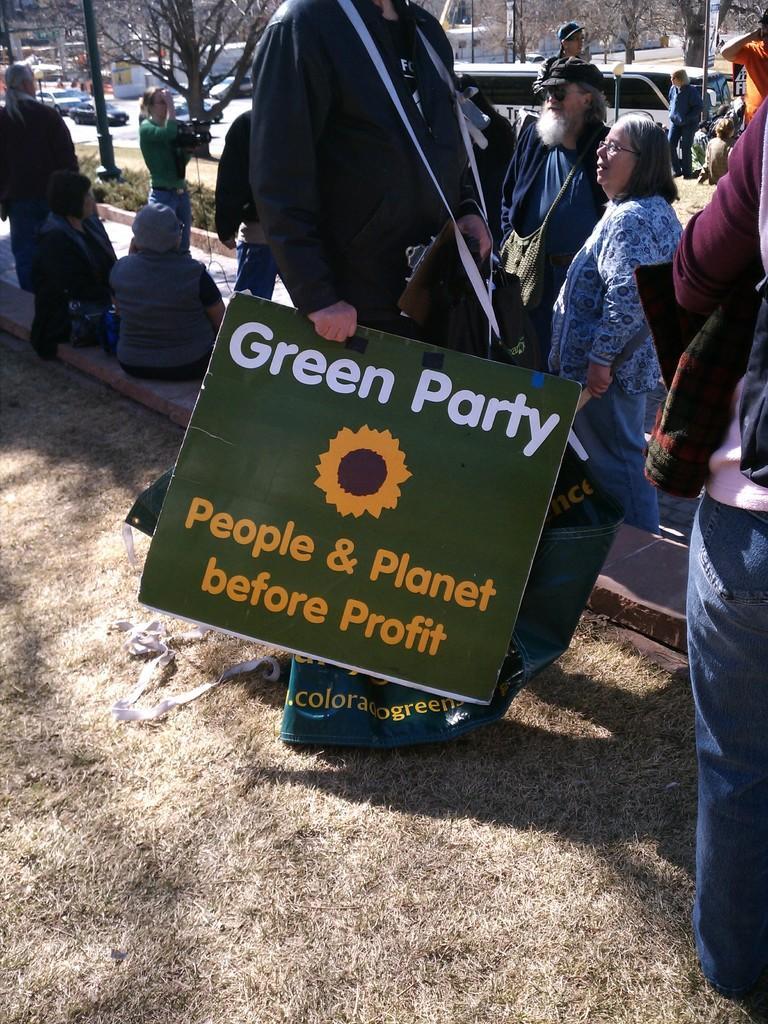Can you describe this image briefly? In the image I can see a person who is holding the board and also I can see some trees, plants, people and some vehicles. 